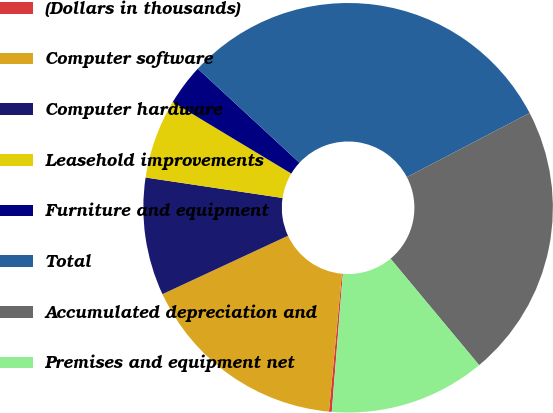Convert chart. <chart><loc_0><loc_0><loc_500><loc_500><pie_chart><fcel>(Dollars in thousands)<fcel>Computer software<fcel>Computer hardware<fcel>Leasehold improvements<fcel>Furniture and equipment<fcel>Total<fcel>Accumulated depreciation and<fcel>Premises and equipment net<nl><fcel>0.22%<fcel>16.58%<fcel>9.29%<fcel>6.27%<fcel>3.25%<fcel>30.46%<fcel>21.61%<fcel>12.32%<nl></chart> 